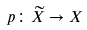Convert formula to latex. <formula><loc_0><loc_0><loc_500><loc_500>p \colon { \widetilde { X } } \to X</formula> 